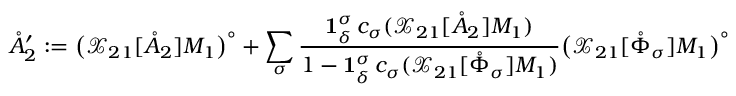<formula> <loc_0><loc_0><loc_500><loc_500>\mathring { A } _ { 2 } ^ { \prime } \colon = \left ( \mathcal { X } _ { 2 1 } [ \mathring { A } _ { 2 } ] M _ { 1 } \right ) ^ { \circ } + \sum _ { \sigma } \frac { 1 _ { \delta } ^ { \sigma } \, c _ { \sigma } ( \mathcal { X } _ { 2 1 } [ \mathring { A } _ { 2 } ] M _ { 1 } ) } { 1 - 1 _ { \delta } ^ { \sigma } \, c _ { \sigma } ( \mathcal { X } _ { 2 1 } [ \mathring { \Phi } _ { \sigma } ] M _ { 1 } ) } \left ( \mathcal { X } _ { 2 1 } [ \mathring { \Phi } _ { \sigma } ] M _ { 1 } \right ) ^ { \circ }</formula> 